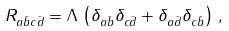<formula> <loc_0><loc_0><loc_500><loc_500>R _ { a \bar { b } c \bar { d } } = \Lambda \, \left ( \delta _ { a \bar { b } } \delta _ { c \bar { d } } + \delta _ { a \bar { d } } \delta _ { c \bar { b } } \right ) \, ,</formula> 